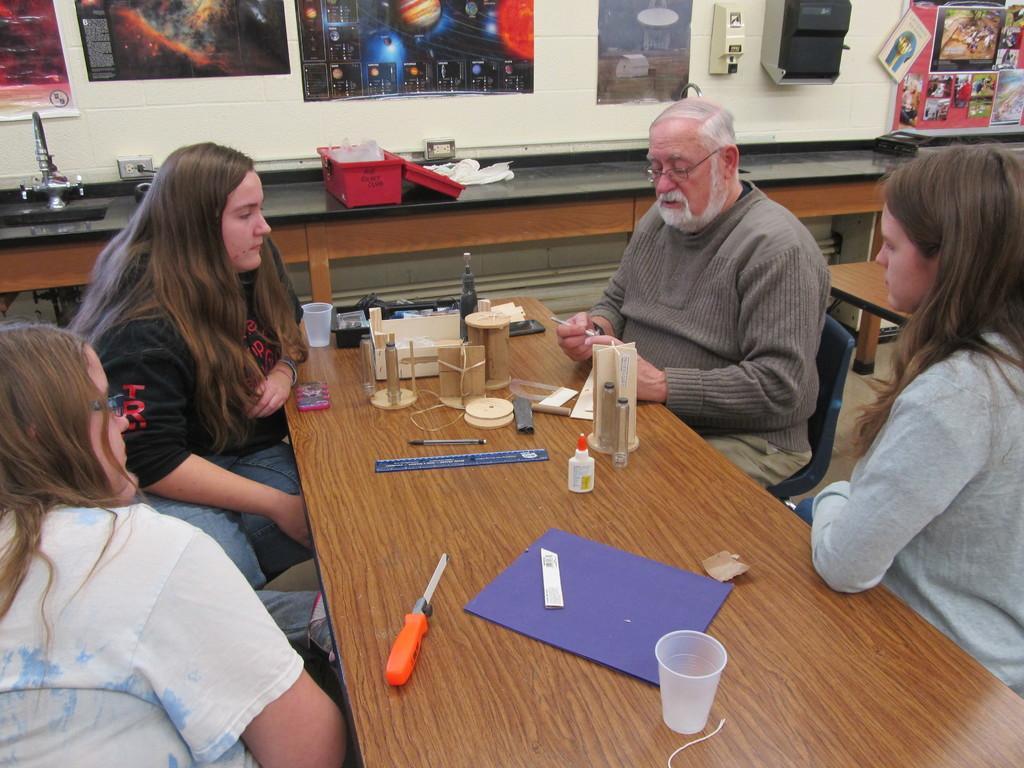Please provide a concise description of this image. There are four people sitting. And there is a table. There are chairs. On the table there are cups, some wooden items, box, driller, glasses, bottles and a pen. In the background there is a wall. There are many paintings. And there is a table. On the table there is a red box and a tap and a sink is over there. 